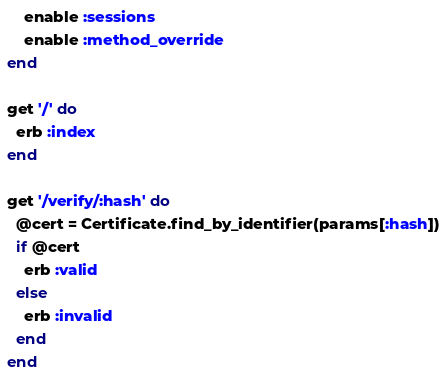<code> <loc_0><loc_0><loc_500><loc_500><_Ruby_>	enable :sessions
	enable :method_override
end

get '/' do
  erb :index
end

get '/verify/:hash' do
  @cert = Certificate.find_by_identifier(params[:hash])
  if @cert
    erb :valid
  else
    erb :invalid
  end
end
</code> 